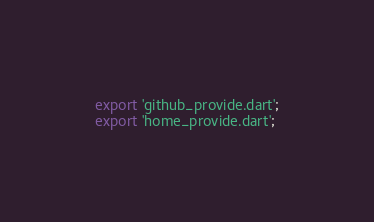<code> <loc_0><loc_0><loc_500><loc_500><_Dart_>export 'github_provide.dart';
export 'home_provide.dart';</code> 